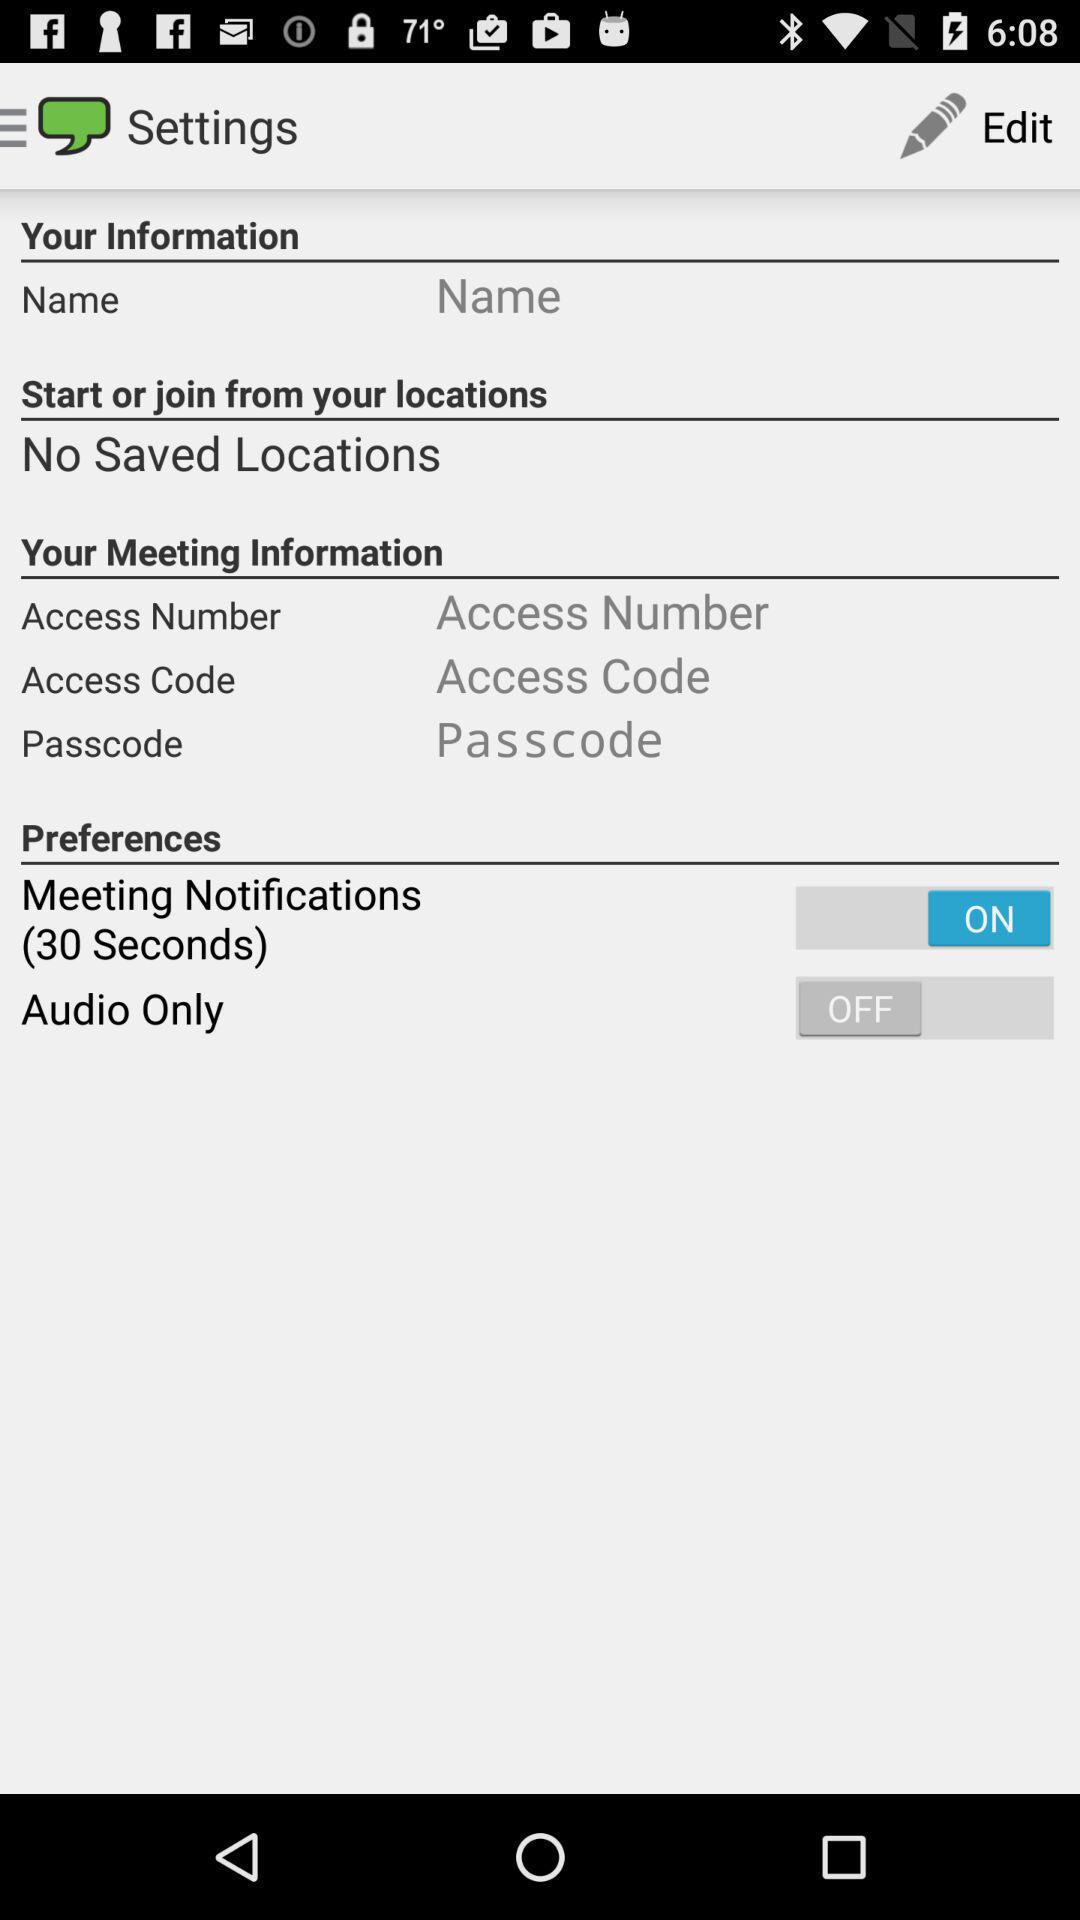How many locations are saved? There are no saved locations. 